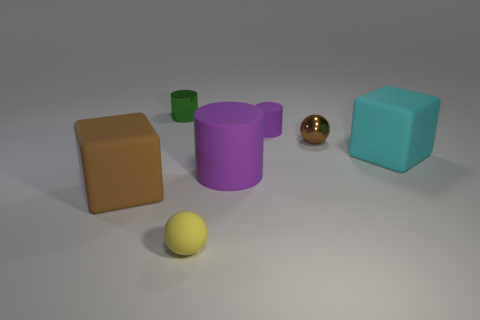What could be the possible function of these objects if they were real and not just models? If these objects were real, they could serve various purposes. The cubes could be building blocks or storage containers, the cylinders might be used as holders or parts of machinery, and the spheres could be decorative elements or sports equipment, depending on their size and material. Could you speculate on the scale of these objects? Without a reference object for scale, it's difficult to determine their exact size. However, if we assume the yellow sphere is the size of a standard tennis ball, then the objects are relatively small, potentially fitting on a tabletop. 